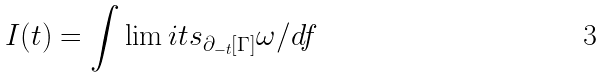<formula> <loc_0><loc_0><loc_500><loc_500>I ( t ) = \int \lim i t s _ { \partial _ { - t } [ \Gamma ] } \omega / d f</formula> 